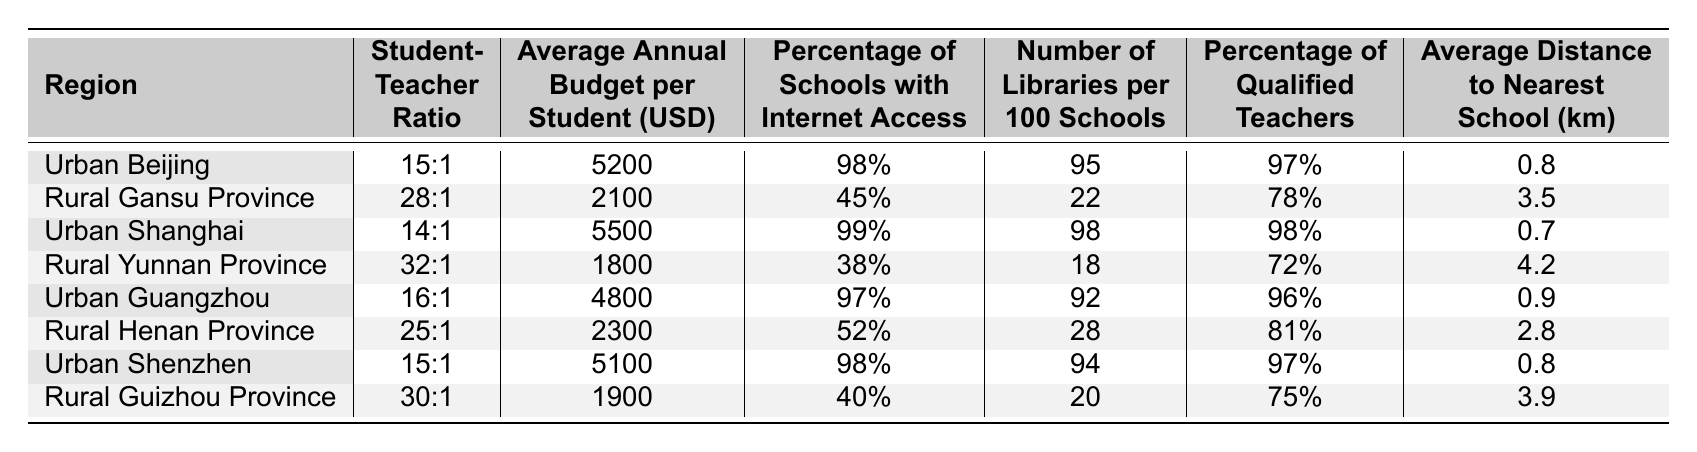What is the student-teacher ratio in Urban Beijing? The table lists the student-teacher ratio for Urban Beijing as 15:1.
Answer: 15:1 Which region has the highest average annual budget per student? By examining the average annual budgets listed, Urban Shanghai has the highest budget at 5500 USD.
Answer: 5500 USD Is the percentage of schools with internet access higher in Urban Guangzhou or Rural Gansu Province? Urban Guangzhou has 97% of schools with internet access, while Rural Gansu Province has 45%. Therefore, Urban Guangzhou has a higher percentage.
Answer: Yes What is the average distance to the nearest school in Rural Yunnan Province? The table indicates that the average distance to the nearest school in Rural Yunnan Province is 4.2 kilometers.
Answer: 4.2 km How many more qualified teachers (percentage) are there in Urban Shanghai compared to Rural Yunnan Province? Urban Shanghai has 98% qualified teachers and Rural Yunnan Province has 72%. The difference is 98% - 72% = 26%.
Answer: 26% Which urban region has the lowest student-teacher ratio? The table shows that Urban Shanghai has the lowest student-teacher ratio at 14:1.
Answer: 14:1 Calculate the average budget per student for all the urban regions listed. The average budget for urban regions is calculated as follows: (5200 + 5500 + 4800 + 5100) / 4 = 5150 USD.
Answer: 5150 USD Is the average annual budget per student in Rural Henan Province higher or lower than the average in Rural Guizhou Province? Rural Henan Province has a budget of 2300 USD, while Rural Guizhou Province has 1900 USD. Since 2300 is greater than 1900, it is higher.
Answer: Higher What is the total number of libraries per 100 schools in Urban Beijing and Urban Shenzhen combined? Adding the libraries: Urban Beijing has 95 and Urban Shenzhen has 94, resulting in 95 + 94 = 189 libraries per 100 schools.
Answer: 189 How many regions have a student-teacher ratio worse than 25:1? The regions with a ratio worse than 25:1 are Rural Gansu Province (28:1), Rural Yunnan Province (32:1), Rural Henan Province (25:1), and Rural Guizhou Province (30:1), totaling four.
Answer: 4 